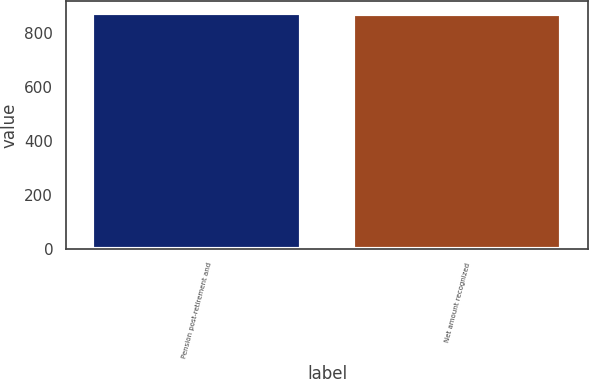<chart> <loc_0><loc_0><loc_500><loc_500><bar_chart><fcel>Pension post-retirement and<fcel>Net amount recognized<nl><fcel>874<fcel>871<nl></chart> 